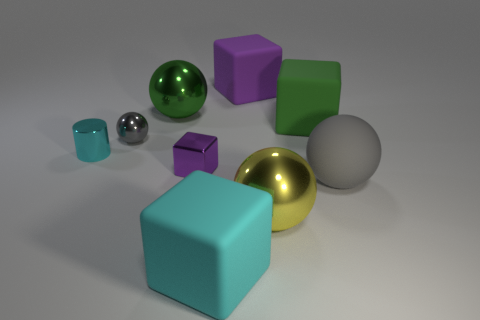How many blocks have the same size as the cylinder?
Give a very brief answer. 1. What shape is the big object behind the green sphere?
Ensure brevity in your answer.  Cube. Are there fewer large purple cubes than big brown matte things?
Offer a terse response. No. There is a gray ball that is on the right side of the big cyan matte block; what is its size?
Provide a succinct answer. Large. Are there more red rubber objects than gray metal balls?
Ensure brevity in your answer.  No. What is the large green block made of?
Offer a very short reply. Rubber. How many other objects are there of the same material as the tiny cyan object?
Keep it short and to the point. 4. What number of brown shiny objects are there?
Your answer should be very brief. 0. What material is the other purple thing that is the same shape as the purple matte thing?
Provide a short and direct response. Metal. Does the purple cube behind the small cyan shiny thing have the same material as the large cyan thing?
Your response must be concise. Yes. 